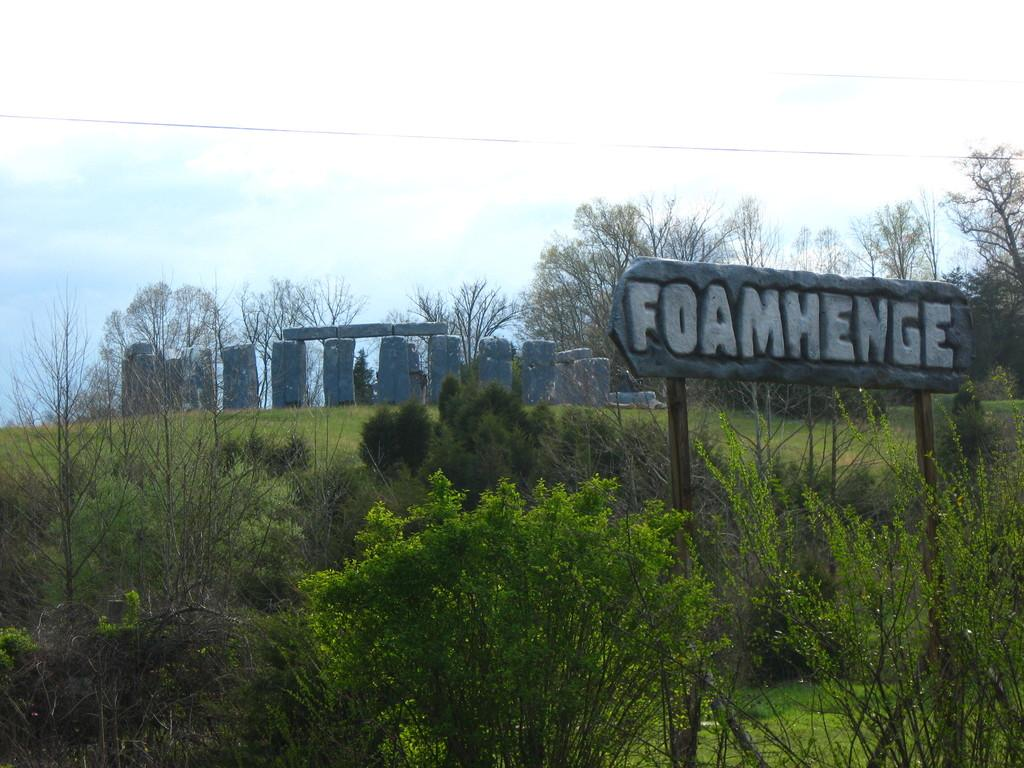What type of natural elements can be seen in the image? There are rocks, grass, plants, and trees visible in the image. What is the ground like in the image? The ground is visible in the image. What is written on the board in the image? There is a board with text in the image. What else can be seen in the image besides the natural elements? There is a wire in the image. What is visible in the sky in the image? The sky is visible in the image, and there are clouds in the sky. What month is it in the image? The month cannot be determined from the image, as there is no information about the time of year. How many children are present in the image? There are no children present in the image. 